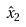<formula> <loc_0><loc_0><loc_500><loc_500>\hat { x } _ { 2 }</formula> 